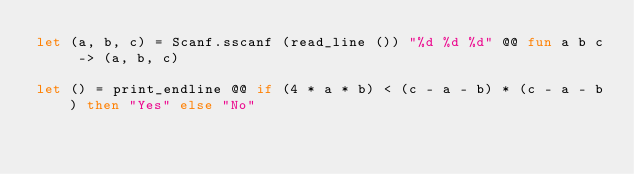<code> <loc_0><loc_0><loc_500><loc_500><_OCaml_>let (a, b, c) = Scanf.sscanf (read_line ()) "%d %d %d" @@ fun a b c -> (a, b, c)

let () = print_endline @@ if (4 * a * b) < (c - a - b) * (c - a - b) then "Yes" else "No"</code> 